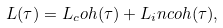Convert formula to latex. <formula><loc_0><loc_0><loc_500><loc_500>L ( \tau ) = L _ { c } o h ( \tau ) + L _ { i } n c o h ( \tau ) ,</formula> 